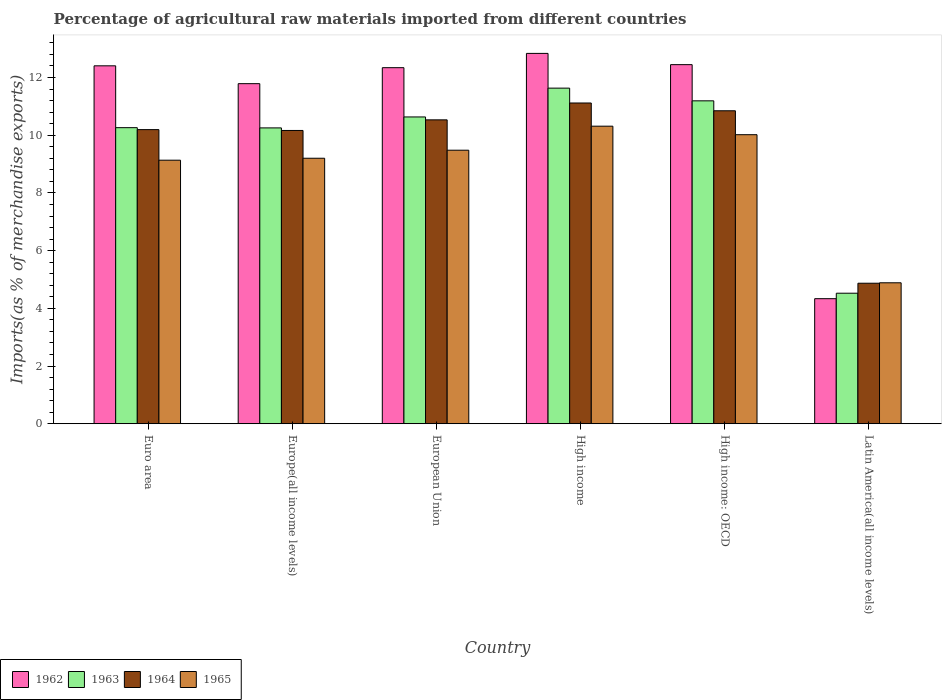How many different coloured bars are there?
Your answer should be very brief. 4. Are the number of bars per tick equal to the number of legend labels?
Give a very brief answer. Yes. Are the number of bars on each tick of the X-axis equal?
Offer a terse response. Yes. How many bars are there on the 6th tick from the left?
Offer a terse response. 4. How many bars are there on the 1st tick from the right?
Offer a very short reply. 4. What is the label of the 5th group of bars from the left?
Your response must be concise. High income: OECD. In how many cases, is the number of bars for a given country not equal to the number of legend labels?
Offer a very short reply. 0. What is the percentage of imports to different countries in 1965 in Latin America(all income levels)?
Give a very brief answer. 4.89. Across all countries, what is the maximum percentage of imports to different countries in 1964?
Your response must be concise. 11.12. Across all countries, what is the minimum percentage of imports to different countries in 1962?
Provide a short and direct response. 4.33. In which country was the percentage of imports to different countries in 1963 maximum?
Offer a very short reply. High income. In which country was the percentage of imports to different countries in 1964 minimum?
Your answer should be very brief. Latin America(all income levels). What is the total percentage of imports to different countries in 1965 in the graph?
Ensure brevity in your answer.  53.03. What is the difference between the percentage of imports to different countries in 1962 in Euro area and that in European Union?
Offer a very short reply. 0.06. What is the difference between the percentage of imports to different countries in 1965 in High income: OECD and the percentage of imports to different countries in 1963 in European Union?
Your response must be concise. -0.62. What is the average percentage of imports to different countries in 1965 per country?
Your response must be concise. 8.84. What is the difference between the percentage of imports to different countries of/in 1963 and percentage of imports to different countries of/in 1965 in Europe(all income levels)?
Keep it short and to the point. 1.05. In how many countries, is the percentage of imports to different countries in 1963 greater than 4 %?
Your answer should be compact. 6. What is the ratio of the percentage of imports to different countries in 1964 in Euro area to that in High income: OECD?
Your answer should be very brief. 0.94. Is the percentage of imports to different countries in 1964 in Euro area less than that in High income?
Provide a short and direct response. Yes. What is the difference between the highest and the second highest percentage of imports to different countries in 1962?
Ensure brevity in your answer.  0.39. What is the difference between the highest and the lowest percentage of imports to different countries in 1965?
Give a very brief answer. 5.43. In how many countries, is the percentage of imports to different countries in 1964 greater than the average percentage of imports to different countries in 1964 taken over all countries?
Keep it short and to the point. 5. Is it the case that in every country, the sum of the percentage of imports to different countries in 1964 and percentage of imports to different countries in 1963 is greater than the sum of percentage of imports to different countries in 1965 and percentage of imports to different countries in 1962?
Keep it short and to the point. No. What does the 4th bar from the left in Europe(all income levels) represents?
Provide a short and direct response. 1965. Is it the case that in every country, the sum of the percentage of imports to different countries in 1965 and percentage of imports to different countries in 1962 is greater than the percentage of imports to different countries in 1964?
Make the answer very short. Yes. How many bars are there?
Offer a terse response. 24. Are all the bars in the graph horizontal?
Ensure brevity in your answer.  No. How many countries are there in the graph?
Offer a terse response. 6. Does the graph contain any zero values?
Provide a succinct answer. No. How many legend labels are there?
Keep it short and to the point. 4. What is the title of the graph?
Keep it short and to the point. Percentage of agricultural raw materials imported from different countries. What is the label or title of the Y-axis?
Make the answer very short. Imports(as % of merchandise exports). What is the Imports(as % of merchandise exports) in 1962 in Euro area?
Your response must be concise. 12.41. What is the Imports(as % of merchandise exports) of 1963 in Euro area?
Offer a terse response. 10.26. What is the Imports(as % of merchandise exports) of 1964 in Euro area?
Give a very brief answer. 10.19. What is the Imports(as % of merchandise exports) of 1965 in Euro area?
Ensure brevity in your answer.  9.13. What is the Imports(as % of merchandise exports) in 1962 in Europe(all income levels)?
Your response must be concise. 11.79. What is the Imports(as % of merchandise exports) in 1963 in Europe(all income levels)?
Provide a succinct answer. 10.25. What is the Imports(as % of merchandise exports) of 1964 in Europe(all income levels)?
Ensure brevity in your answer.  10.17. What is the Imports(as % of merchandise exports) in 1965 in Europe(all income levels)?
Give a very brief answer. 9.2. What is the Imports(as % of merchandise exports) of 1962 in European Union?
Provide a short and direct response. 12.34. What is the Imports(as % of merchandise exports) of 1963 in European Union?
Your response must be concise. 10.63. What is the Imports(as % of merchandise exports) of 1964 in European Union?
Your answer should be very brief. 10.53. What is the Imports(as % of merchandise exports) in 1965 in European Union?
Offer a very short reply. 9.48. What is the Imports(as % of merchandise exports) in 1962 in High income?
Provide a short and direct response. 12.84. What is the Imports(as % of merchandise exports) of 1963 in High income?
Make the answer very short. 11.63. What is the Imports(as % of merchandise exports) in 1964 in High income?
Your answer should be compact. 11.12. What is the Imports(as % of merchandise exports) of 1965 in High income?
Offer a terse response. 10.31. What is the Imports(as % of merchandise exports) in 1962 in High income: OECD?
Your response must be concise. 12.45. What is the Imports(as % of merchandise exports) in 1963 in High income: OECD?
Your answer should be compact. 11.19. What is the Imports(as % of merchandise exports) of 1964 in High income: OECD?
Ensure brevity in your answer.  10.85. What is the Imports(as % of merchandise exports) in 1965 in High income: OECD?
Offer a terse response. 10.02. What is the Imports(as % of merchandise exports) in 1962 in Latin America(all income levels)?
Make the answer very short. 4.33. What is the Imports(as % of merchandise exports) in 1963 in Latin America(all income levels)?
Provide a short and direct response. 4.52. What is the Imports(as % of merchandise exports) in 1964 in Latin America(all income levels)?
Provide a succinct answer. 4.87. What is the Imports(as % of merchandise exports) of 1965 in Latin America(all income levels)?
Keep it short and to the point. 4.89. Across all countries, what is the maximum Imports(as % of merchandise exports) in 1962?
Give a very brief answer. 12.84. Across all countries, what is the maximum Imports(as % of merchandise exports) of 1963?
Make the answer very short. 11.63. Across all countries, what is the maximum Imports(as % of merchandise exports) of 1964?
Offer a very short reply. 11.12. Across all countries, what is the maximum Imports(as % of merchandise exports) of 1965?
Give a very brief answer. 10.31. Across all countries, what is the minimum Imports(as % of merchandise exports) in 1962?
Give a very brief answer. 4.33. Across all countries, what is the minimum Imports(as % of merchandise exports) in 1963?
Offer a terse response. 4.52. Across all countries, what is the minimum Imports(as % of merchandise exports) of 1964?
Keep it short and to the point. 4.87. Across all countries, what is the minimum Imports(as % of merchandise exports) of 1965?
Make the answer very short. 4.89. What is the total Imports(as % of merchandise exports) of 1962 in the graph?
Offer a terse response. 66.15. What is the total Imports(as % of merchandise exports) of 1963 in the graph?
Your answer should be compact. 58.5. What is the total Imports(as % of merchandise exports) in 1964 in the graph?
Offer a terse response. 57.73. What is the total Imports(as % of merchandise exports) of 1965 in the graph?
Provide a succinct answer. 53.03. What is the difference between the Imports(as % of merchandise exports) of 1962 in Euro area and that in Europe(all income levels)?
Offer a terse response. 0.62. What is the difference between the Imports(as % of merchandise exports) of 1963 in Euro area and that in Europe(all income levels)?
Give a very brief answer. 0.01. What is the difference between the Imports(as % of merchandise exports) of 1964 in Euro area and that in Europe(all income levels)?
Offer a terse response. 0.03. What is the difference between the Imports(as % of merchandise exports) of 1965 in Euro area and that in Europe(all income levels)?
Your response must be concise. -0.07. What is the difference between the Imports(as % of merchandise exports) in 1962 in Euro area and that in European Union?
Give a very brief answer. 0.06. What is the difference between the Imports(as % of merchandise exports) of 1963 in Euro area and that in European Union?
Your answer should be compact. -0.37. What is the difference between the Imports(as % of merchandise exports) of 1964 in Euro area and that in European Union?
Provide a short and direct response. -0.34. What is the difference between the Imports(as % of merchandise exports) of 1965 in Euro area and that in European Union?
Your response must be concise. -0.35. What is the difference between the Imports(as % of merchandise exports) of 1962 in Euro area and that in High income?
Your response must be concise. -0.43. What is the difference between the Imports(as % of merchandise exports) in 1963 in Euro area and that in High income?
Keep it short and to the point. -1.37. What is the difference between the Imports(as % of merchandise exports) in 1964 in Euro area and that in High income?
Your answer should be very brief. -0.92. What is the difference between the Imports(as % of merchandise exports) of 1965 in Euro area and that in High income?
Give a very brief answer. -1.18. What is the difference between the Imports(as % of merchandise exports) in 1962 in Euro area and that in High income: OECD?
Ensure brevity in your answer.  -0.04. What is the difference between the Imports(as % of merchandise exports) of 1963 in Euro area and that in High income: OECD?
Give a very brief answer. -0.93. What is the difference between the Imports(as % of merchandise exports) of 1964 in Euro area and that in High income: OECD?
Offer a terse response. -0.65. What is the difference between the Imports(as % of merchandise exports) in 1965 in Euro area and that in High income: OECD?
Offer a very short reply. -0.88. What is the difference between the Imports(as % of merchandise exports) in 1962 in Euro area and that in Latin America(all income levels)?
Make the answer very short. 8.07. What is the difference between the Imports(as % of merchandise exports) in 1963 in Euro area and that in Latin America(all income levels)?
Your answer should be very brief. 5.74. What is the difference between the Imports(as % of merchandise exports) of 1964 in Euro area and that in Latin America(all income levels)?
Provide a succinct answer. 5.32. What is the difference between the Imports(as % of merchandise exports) of 1965 in Euro area and that in Latin America(all income levels)?
Make the answer very short. 4.25. What is the difference between the Imports(as % of merchandise exports) in 1962 in Europe(all income levels) and that in European Union?
Give a very brief answer. -0.55. What is the difference between the Imports(as % of merchandise exports) of 1963 in Europe(all income levels) and that in European Union?
Provide a short and direct response. -0.38. What is the difference between the Imports(as % of merchandise exports) of 1964 in Europe(all income levels) and that in European Union?
Your response must be concise. -0.37. What is the difference between the Imports(as % of merchandise exports) of 1965 in Europe(all income levels) and that in European Union?
Provide a short and direct response. -0.28. What is the difference between the Imports(as % of merchandise exports) in 1962 in Europe(all income levels) and that in High income?
Provide a short and direct response. -1.05. What is the difference between the Imports(as % of merchandise exports) of 1963 in Europe(all income levels) and that in High income?
Your answer should be very brief. -1.38. What is the difference between the Imports(as % of merchandise exports) in 1964 in Europe(all income levels) and that in High income?
Your answer should be very brief. -0.95. What is the difference between the Imports(as % of merchandise exports) in 1965 in Europe(all income levels) and that in High income?
Ensure brevity in your answer.  -1.11. What is the difference between the Imports(as % of merchandise exports) in 1962 in Europe(all income levels) and that in High income: OECD?
Your answer should be compact. -0.66. What is the difference between the Imports(as % of merchandise exports) in 1963 in Europe(all income levels) and that in High income: OECD?
Offer a very short reply. -0.94. What is the difference between the Imports(as % of merchandise exports) of 1964 in Europe(all income levels) and that in High income: OECD?
Keep it short and to the point. -0.68. What is the difference between the Imports(as % of merchandise exports) in 1965 in Europe(all income levels) and that in High income: OECD?
Provide a succinct answer. -0.82. What is the difference between the Imports(as % of merchandise exports) of 1962 in Europe(all income levels) and that in Latin America(all income levels)?
Keep it short and to the point. 7.45. What is the difference between the Imports(as % of merchandise exports) in 1963 in Europe(all income levels) and that in Latin America(all income levels)?
Keep it short and to the point. 5.73. What is the difference between the Imports(as % of merchandise exports) in 1964 in Europe(all income levels) and that in Latin America(all income levels)?
Give a very brief answer. 5.29. What is the difference between the Imports(as % of merchandise exports) of 1965 in Europe(all income levels) and that in Latin America(all income levels)?
Give a very brief answer. 4.32. What is the difference between the Imports(as % of merchandise exports) in 1962 in European Union and that in High income?
Give a very brief answer. -0.5. What is the difference between the Imports(as % of merchandise exports) of 1963 in European Union and that in High income?
Your response must be concise. -1. What is the difference between the Imports(as % of merchandise exports) of 1964 in European Union and that in High income?
Your answer should be compact. -0.58. What is the difference between the Imports(as % of merchandise exports) in 1965 in European Union and that in High income?
Your answer should be very brief. -0.83. What is the difference between the Imports(as % of merchandise exports) of 1962 in European Union and that in High income: OECD?
Your answer should be very brief. -0.11. What is the difference between the Imports(as % of merchandise exports) of 1963 in European Union and that in High income: OECD?
Your answer should be compact. -0.56. What is the difference between the Imports(as % of merchandise exports) in 1964 in European Union and that in High income: OECD?
Give a very brief answer. -0.31. What is the difference between the Imports(as % of merchandise exports) of 1965 in European Union and that in High income: OECD?
Make the answer very short. -0.54. What is the difference between the Imports(as % of merchandise exports) of 1962 in European Union and that in Latin America(all income levels)?
Ensure brevity in your answer.  8.01. What is the difference between the Imports(as % of merchandise exports) of 1963 in European Union and that in Latin America(all income levels)?
Provide a short and direct response. 6.11. What is the difference between the Imports(as % of merchandise exports) in 1964 in European Union and that in Latin America(all income levels)?
Keep it short and to the point. 5.66. What is the difference between the Imports(as % of merchandise exports) of 1965 in European Union and that in Latin America(all income levels)?
Offer a terse response. 4.59. What is the difference between the Imports(as % of merchandise exports) of 1962 in High income and that in High income: OECD?
Offer a very short reply. 0.39. What is the difference between the Imports(as % of merchandise exports) in 1963 in High income and that in High income: OECD?
Ensure brevity in your answer.  0.44. What is the difference between the Imports(as % of merchandise exports) of 1964 in High income and that in High income: OECD?
Make the answer very short. 0.27. What is the difference between the Imports(as % of merchandise exports) of 1965 in High income and that in High income: OECD?
Give a very brief answer. 0.3. What is the difference between the Imports(as % of merchandise exports) of 1962 in High income and that in Latin America(all income levels)?
Make the answer very short. 8.5. What is the difference between the Imports(as % of merchandise exports) in 1963 in High income and that in Latin America(all income levels)?
Provide a short and direct response. 7.11. What is the difference between the Imports(as % of merchandise exports) of 1964 in High income and that in Latin America(all income levels)?
Keep it short and to the point. 6.25. What is the difference between the Imports(as % of merchandise exports) in 1965 in High income and that in Latin America(all income levels)?
Provide a short and direct response. 5.43. What is the difference between the Imports(as % of merchandise exports) in 1962 in High income: OECD and that in Latin America(all income levels)?
Ensure brevity in your answer.  8.11. What is the difference between the Imports(as % of merchandise exports) in 1963 in High income: OECD and that in Latin America(all income levels)?
Give a very brief answer. 6.67. What is the difference between the Imports(as % of merchandise exports) in 1964 in High income: OECD and that in Latin America(all income levels)?
Your answer should be compact. 5.98. What is the difference between the Imports(as % of merchandise exports) in 1965 in High income: OECD and that in Latin America(all income levels)?
Offer a terse response. 5.13. What is the difference between the Imports(as % of merchandise exports) of 1962 in Euro area and the Imports(as % of merchandise exports) of 1963 in Europe(all income levels)?
Offer a terse response. 2.15. What is the difference between the Imports(as % of merchandise exports) of 1962 in Euro area and the Imports(as % of merchandise exports) of 1964 in Europe(all income levels)?
Offer a terse response. 2.24. What is the difference between the Imports(as % of merchandise exports) in 1962 in Euro area and the Imports(as % of merchandise exports) in 1965 in Europe(all income levels)?
Keep it short and to the point. 3.2. What is the difference between the Imports(as % of merchandise exports) of 1963 in Euro area and the Imports(as % of merchandise exports) of 1964 in Europe(all income levels)?
Keep it short and to the point. 0.1. What is the difference between the Imports(as % of merchandise exports) in 1963 in Euro area and the Imports(as % of merchandise exports) in 1965 in Europe(all income levels)?
Provide a succinct answer. 1.06. What is the difference between the Imports(as % of merchandise exports) of 1962 in Euro area and the Imports(as % of merchandise exports) of 1963 in European Union?
Your response must be concise. 1.77. What is the difference between the Imports(as % of merchandise exports) of 1962 in Euro area and the Imports(as % of merchandise exports) of 1964 in European Union?
Ensure brevity in your answer.  1.87. What is the difference between the Imports(as % of merchandise exports) of 1962 in Euro area and the Imports(as % of merchandise exports) of 1965 in European Union?
Your answer should be very brief. 2.93. What is the difference between the Imports(as % of merchandise exports) in 1963 in Euro area and the Imports(as % of merchandise exports) in 1964 in European Union?
Ensure brevity in your answer.  -0.27. What is the difference between the Imports(as % of merchandise exports) of 1963 in Euro area and the Imports(as % of merchandise exports) of 1965 in European Union?
Offer a terse response. 0.78. What is the difference between the Imports(as % of merchandise exports) in 1964 in Euro area and the Imports(as % of merchandise exports) in 1965 in European Union?
Make the answer very short. 0.71. What is the difference between the Imports(as % of merchandise exports) of 1962 in Euro area and the Imports(as % of merchandise exports) of 1963 in High income?
Give a very brief answer. 0.77. What is the difference between the Imports(as % of merchandise exports) in 1962 in Euro area and the Imports(as % of merchandise exports) in 1964 in High income?
Your response must be concise. 1.29. What is the difference between the Imports(as % of merchandise exports) of 1962 in Euro area and the Imports(as % of merchandise exports) of 1965 in High income?
Your answer should be compact. 2.09. What is the difference between the Imports(as % of merchandise exports) of 1963 in Euro area and the Imports(as % of merchandise exports) of 1964 in High income?
Ensure brevity in your answer.  -0.86. What is the difference between the Imports(as % of merchandise exports) of 1963 in Euro area and the Imports(as % of merchandise exports) of 1965 in High income?
Your response must be concise. -0.05. What is the difference between the Imports(as % of merchandise exports) of 1964 in Euro area and the Imports(as % of merchandise exports) of 1965 in High income?
Your answer should be very brief. -0.12. What is the difference between the Imports(as % of merchandise exports) in 1962 in Euro area and the Imports(as % of merchandise exports) in 1963 in High income: OECD?
Give a very brief answer. 1.21. What is the difference between the Imports(as % of merchandise exports) in 1962 in Euro area and the Imports(as % of merchandise exports) in 1964 in High income: OECD?
Give a very brief answer. 1.56. What is the difference between the Imports(as % of merchandise exports) of 1962 in Euro area and the Imports(as % of merchandise exports) of 1965 in High income: OECD?
Your response must be concise. 2.39. What is the difference between the Imports(as % of merchandise exports) in 1963 in Euro area and the Imports(as % of merchandise exports) in 1964 in High income: OECD?
Provide a succinct answer. -0.59. What is the difference between the Imports(as % of merchandise exports) in 1963 in Euro area and the Imports(as % of merchandise exports) in 1965 in High income: OECD?
Ensure brevity in your answer.  0.24. What is the difference between the Imports(as % of merchandise exports) in 1964 in Euro area and the Imports(as % of merchandise exports) in 1965 in High income: OECD?
Offer a terse response. 0.18. What is the difference between the Imports(as % of merchandise exports) in 1962 in Euro area and the Imports(as % of merchandise exports) in 1963 in Latin America(all income levels)?
Your answer should be very brief. 7.88. What is the difference between the Imports(as % of merchandise exports) in 1962 in Euro area and the Imports(as % of merchandise exports) in 1964 in Latin America(all income levels)?
Keep it short and to the point. 7.54. What is the difference between the Imports(as % of merchandise exports) in 1962 in Euro area and the Imports(as % of merchandise exports) in 1965 in Latin America(all income levels)?
Your answer should be very brief. 7.52. What is the difference between the Imports(as % of merchandise exports) of 1963 in Euro area and the Imports(as % of merchandise exports) of 1964 in Latin America(all income levels)?
Your answer should be compact. 5.39. What is the difference between the Imports(as % of merchandise exports) in 1963 in Euro area and the Imports(as % of merchandise exports) in 1965 in Latin America(all income levels)?
Provide a succinct answer. 5.38. What is the difference between the Imports(as % of merchandise exports) in 1964 in Euro area and the Imports(as % of merchandise exports) in 1965 in Latin America(all income levels)?
Your answer should be compact. 5.31. What is the difference between the Imports(as % of merchandise exports) in 1962 in Europe(all income levels) and the Imports(as % of merchandise exports) in 1963 in European Union?
Offer a terse response. 1.15. What is the difference between the Imports(as % of merchandise exports) of 1962 in Europe(all income levels) and the Imports(as % of merchandise exports) of 1964 in European Union?
Keep it short and to the point. 1.25. What is the difference between the Imports(as % of merchandise exports) in 1962 in Europe(all income levels) and the Imports(as % of merchandise exports) in 1965 in European Union?
Provide a succinct answer. 2.31. What is the difference between the Imports(as % of merchandise exports) in 1963 in Europe(all income levels) and the Imports(as % of merchandise exports) in 1964 in European Union?
Offer a very short reply. -0.28. What is the difference between the Imports(as % of merchandise exports) of 1963 in Europe(all income levels) and the Imports(as % of merchandise exports) of 1965 in European Union?
Offer a very short reply. 0.77. What is the difference between the Imports(as % of merchandise exports) in 1964 in Europe(all income levels) and the Imports(as % of merchandise exports) in 1965 in European Union?
Ensure brevity in your answer.  0.68. What is the difference between the Imports(as % of merchandise exports) of 1962 in Europe(all income levels) and the Imports(as % of merchandise exports) of 1963 in High income?
Make the answer very short. 0.15. What is the difference between the Imports(as % of merchandise exports) in 1962 in Europe(all income levels) and the Imports(as % of merchandise exports) in 1964 in High income?
Your answer should be very brief. 0.67. What is the difference between the Imports(as % of merchandise exports) of 1962 in Europe(all income levels) and the Imports(as % of merchandise exports) of 1965 in High income?
Your response must be concise. 1.47. What is the difference between the Imports(as % of merchandise exports) in 1963 in Europe(all income levels) and the Imports(as % of merchandise exports) in 1964 in High income?
Ensure brevity in your answer.  -0.86. What is the difference between the Imports(as % of merchandise exports) in 1963 in Europe(all income levels) and the Imports(as % of merchandise exports) in 1965 in High income?
Your answer should be compact. -0.06. What is the difference between the Imports(as % of merchandise exports) of 1964 in Europe(all income levels) and the Imports(as % of merchandise exports) of 1965 in High income?
Ensure brevity in your answer.  -0.15. What is the difference between the Imports(as % of merchandise exports) of 1962 in Europe(all income levels) and the Imports(as % of merchandise exports) of 1963 in High income: OECD?
Ensure brevity in your answer.  0.59. What is the difference between the Imports(as % of merchandise exports) of 1962 in Europe(all income levels) and the Imports(as % of merchandise exports) of 1964 in High income: OECD?
Provide a succinct answer. 0.94. What is the difference between the Imports(as % of merchandise exports) in 1962 in Europe(all income levels) and the Imports(as % of merchandise exports) in 1965 in High income: OECD?
Your answer should be very brief. 1.77. What is the difference between the Imports(as % of merchandise exports) in 1963 in Europe(all income levels) and the Imports(as % of merchandise exports) in 1964 in High income: OECD?
Your answer should be very brief. -0.59. What is the difference between the Imports(as % of merchandise exports) in 1963 in Europe(all income levels) and the Imports(as % of merchandise exports) in 1965 in High income: OECD?
Make the answer very short. 0.24. What is the difference between the Imports(as % of merchandise exports) in 1964 in Europe(all income levels) and the Imports(as % of merchandise exports) in 1965 in High income: OECD?
Your response must be concise. 0.15. What is the difference between the Imports(as % of merchandise exports) of 1962 in Europe(all income levels) and the Imports(as % of merchandise exports) of 1963 in Latin America(all income levels)?
Keep it short and to the point. 7.26. What is the difference between the Imports(as % of merchandise exports) in 1962 in Europe(all income levels) and the Imports(as % of merchandise exports) in 1964 in Latin America(all income levels)?
Ensure brevity in your answer.  6.92. What is the difference between the Imports(as % of merchandise exports) in 1962 in Europe(all income levels) and the Imports(as % of merchandise exports) in 1965 in Latin America(all income levels)?
Ensure brevity in your answer.  6.9. What is the difference between the Imports(as % of merchandise exports) in 1963 in Europe(all income levels) and the Imports(as % of merchandise exports) in 1964 in Latin America(all income levels)?
Keep it short and to the point. 5.38. What is the difference between the Imports(as % of merchandise exports) of 1963 in Europe(all income levels) and the Imports(as % of merchandise exports) of 1965 in Latin America(all income levels)?
Your answer should be compact. 5.37. What is the difference between the Imports(as % of merchandise exports) of 1964 in Europe(all income levels) and the Imports(as % of merchandise exports) of 1965 in Latin America(all income levels)?
Ensure brevity in your answer.  5.28. What is the difference between the Imports(as % of merchandise exports) in 1962 in European Union and the Imports(as % of merchandise exports) in 1963 in High income?
Offer a very short reply. 0.71. What is the difference between the Imports(as % of merchandise exports) of 1962 in European Union and the Imports(as % of merchandise exports) of 1964 in High income?
Provide a succinct answer. 1.22. What is the difference between the Imports(as % of merchandise exports) in 1962 in European Union and the Imports(as % of merchandise exports) in 1965 in High income?
Your answer should be very brief. 2.03. What is the difference between the Imports(as % of merchandise exports) in 1963 in European Union and the Imports(as % of merchandise exports) in 1964 in High income?
Offer a very short reply. -0.48. What is the difference between the Imports(as % of merchandise exports) in 1963 in European Union and the Imports(as % of merchandise exports) in 1965 in High income?
Your answer should be very brief. 0.32. What is the difference between the Imports(as % of merchandise exports) in 1964 in European Union and the Imports(as % of merchandise exports) in 1965 in High income?
Offer a terse response. 0.22. What is the difference between the Imports(as % of merchandise exports) of 1962 in European Union and the Imports(as % of merchandise exports) of 1963 in High income: OECD?
Your answer should be very brief. 1.15. What is the difference between the Imports(as % of merchandise exports) of 1962 in European Union and the Imports(as % of merchandise exports) of 1964 in High income: OECD?
Your answer should be compact. 1.49. What is the difference between the Imports(as % of merchandise exports) of 1962 in European Union and the Imports(as % of merchandise exports) of 1965 in High income: OECD?
Your answer should be very brief. 2.32. What is the difference between the Imports(as % of merchandise exports) of 1963 in European Union and the Imports(as % of merchandise exports) of 1964 in High income: OECD?
Make the answer very short. -0.21. What is the difference between the Imports(as % of merchandise exports) in 1963 in European Union and the Imports(as % of merchandise exports) in 1965 in High income: OECD?
Offer a very short reply. 0.62. What is the difference between the Imports(as % of merchandise exports) in 1964 in European Union and the Imports(as % of merchandise exports) in 1965 in High income: OECD?
Your answer should be compact. 0.51. What is the difference between the Imports(as % of merchandise exports) in 1962 in European Union and the Imports(as % of merchandise exports) in 1963 in Latin America(all income levels)?
Make the answer very short. 7.82. What is the difference between the Imports(as % of merchandise exports) in 1962 in European Union and the Imports(as % of merchandise exports) in 1964 in Latin America(all income levels)?
Ensure brevity in your answer.  7.47. What is the difference between the Imports(as % of merchandise exports) of 1962 in European Union and the Imports(as % of merchandise exports) of 1965 in Latin America(all income levels)?
Provide a short and direct response. 7.46. What is the difference between the Imports(as % of merchandise exports) in 1963 in European Union and the Imports(as % of merchandise exports) in 1964 in Latin America(all income levels)?
Provide a succinct answer. 5.76. What is the difference between the Imports(as % of merchandise exports) in 1963 in European Union and the Imports(as % of merchandise exports) in 1965 in Latin America(all income levels)?
Make the answer very short. 5.75. What is the difference between the Imports(as % of merchandise exports) of 1964 in European Union and the Imports(as % of merchandise exports) of 1965 in Latin America(all income levels)?
Provide a succinct answer. 5.65. What is the difference between the Imports(as % of merchandise exports) of 1962 in High income and the Imports(as % of merchandise exports) of 1963 in High income: OECD?
Ensure brevity in your answer.  1.64. What is the difference between the Imports(as % of merchandise exports) in 1962 in High income and the Imports(as % of merchandise exports) in 1964 in High income: OECD?
Give a very brief answer. 1.99. What is the difference between the Imports(as % of merchandise exports) of 1962 in High income and the Imports(as % of merchandise exports) of 1965 in High income: OECD?
Keep it short and to the point. 2.82. What is the difference between the Imports(as % of merchandise exports) in 1963 in High income and the Imports(as % of merchandise exports) in 1964 in High income: OECD?
Ensure brevity in your answer.  0.78. What is the difference between the Imports(as % of merchandise exports) of 1963 in High income and the Imports(as % of merchandise exports) of 1965 in High income: OECD?
Your answer should be compact. 1.61. What is the difference between the Imports(as % of merchandise exports) in 1964 in High income and the Imports(as % of merchandise exports) in 1965 in High income: OECD?
Your answer should be very brief. 1.1. What is the difference between the Imports(as % of merchandise exports) in 1962 in High income and the Imports(as % of merchandise exports) in 1963 in Latin America(all income levels)?
Offer a very short reply. 8.31. What is the difference between the Imports(as % of merchandise exports) in 1962 in High income and the Imports(as % of merchandise exports) in 1964 in Latin America(all income levels)?
Give a very brief answer. 7.97. What is the difference between the Imports(as % of merchandise exports) of 1962 in High income and the Imports(as % of merchandise exports) of 1965 in Latin America(all income levels)?
Keep it short and to the point. 7.95. What is the difference between the Imports(as % of merchandise exports) in 1963 in High income and the Imports(as % of merchandise exports) in 1964 in Latin America(all income levels)?
Your answer should be very brief. 6.76. What is the difference between the Imports(as % of merchandise exports) of 1963 in High income and the Imports(as % of merchandise exports) of 1965 in Latin America(all income levels)?
Offer a very short reply. 6.75. What is the difference between the Imports(as % of merchandise exports) of 1964 in High income and the Imports(as % of merchandise exports) of 1965 in Latin America(all income levels)?
Provide a short and direct response. 6.23. What is the difference between the Imports(as % of merchandise exports) in 1962 in High income: OECD and the Imports(as % of merchandise exports) in 1963 in Latin America(all income levels)?
Give a very brief answer. 7.92. What is the difference between the Imports(as % of merchandise exports) of 1962 in High income: OECD and the Imports(as % of merchandise exports) of 1964 in Latin America(all income levels)?
Your response must be concise. 7.58. What is the difference between the Imports(as % of merchandise exports) of 1962 in High income: OECD and the Imports(as % of merchandise exports) of 1965 in Latin America(all income levels)?
Your response must be concise. 7.56. What is the difference between the Imports(as % of merchandise exports) in 1963 in High income: OECD and the Imports(as % of merchandise exports) in 1964 in Latin America(all income levels)?
Provide a short and direct response. 6.32. What is the difference between the Imports(as % of merchandise exports) in 1963 in High income: OECD and the Imports(as % of merchandise exports) in 1965 in Latin America(all income levels)?
Offer a very short reply. 6.31. What is the difference between the Imports(as % of merchandise exports) in 1964 in High income: OECD and the Imports(as % of merchandise exports) in 1965 in Latin America(all income levels)?
Make the answer very short. 5.96. What is the average Imports(as % of merchandise exports) in 1962 per country?
Ensure brevity in your answer.  11.03. What is the average Imports(as % of merchandise exports) in 1963 per country?
Offer a very short reply. 9.75. What is the average Imports(as % of merchandise exports) of 1964 per country?
Your answer should be compact. 9.62. What is the average Imports(as % of merchandise exports) of 1965 per country?
Make the answer very short. 8.84. What is the difference between the Imports(as % of merchandise exports) in 1962 and Imports(as % of merchandise exports) in 1963 in Euro area?
Your response must be concise. 2.14. What is the difference between the Imports(as % of merchandise exports) of 1962 and Imports(as % of merchandise exports) of 1964 in Euro area?
Offer a very short reply. 2.21. What is the difference between the Imports(as % of merchandise exports) of 1962 and Imports(as % of merchandise exports) of 1965 in Euro area?
Offer a very short reply. 3.27. What is the difference between the Imports(as % of merchandise exports) in 1963 and Imports(as % of merchandise exports) in 1964 in Euro area?
Keep it short and to the point. 0.07. What is the difference between the Imports(as % of merchandise exports) in 1963 and Imports(as % of merchandise exports) in 1965 in Euro area?
Offer a very short reply. 1.13. What is the difference between the Imports(as % of merchandise exports) of 1964 and Imports(as % of merchandise exports) of 1965 in Euro area?
Your answer should be very brief. 1.06. What is the difference between the Imports(as % of merchandise exports) of 1962 and Imports(as % of merchandise exports) of 1963 in Europe(all income levels)?
Make the answer very short. 1.53. What is the difference between the Imports(as % of merchandise exports) of 1962 and Imports(as % of merchandise exports) of 1964 in Europe(all income levels)?
Ensure brevity in your answer.  1.62. What is the difference between the Imports(as % of merchandise exports) in 1962 and Imports(as % of merchandise exports) in 1965 in Europe(all income levels)?
Your answer should be very brief. 2.58. What is the difference between the Imports(as % of merchandise exports) in 1963 and Imports(as % of merchandise exports) in 1964 in Europe(all income levels)?
Provide a short and direct response. 0.09. What is the difference between the Imports(as % of merchandise exports) in 1963 and Imports(as % of merchandise exports) in 1965 in Europe(all income levels)?
Offer a very short reply. 1.05. What is the difference between the Imports(as % of merchandise exports) in 1964 and Imports(as % of merchandise exports) in 1965 in Europe(all income levels)?
Ensure brevity in your answer.  0.96. What is the difference between the Imports(as % of merchandise exports) in 1962 and Imports(as % of merchandise exports) in 1963 in European Union?
Your answer should be compact. 1.71. What is the difference between the Imports(as % of merchandise exports) of 1962 and Imports(as % of merchandise exports) of 1964 in European Union?
Keep it short and to the point. 1.81. What is the difference between the Imports(as % of merchandise exports) in 1962 and Imports(as % of merchandise exports) in 1965 in European Union?
Your answer should be very brief. 2.86. What is the difference between the Imports(as % of merchandise exports) of 1963 and Imports(as % of merchandise exports) of 1964 in European Union?
Provide a short and direct response. 0.1. What is the difference between the Imports(as % of merchandise exports) in 1963 and Imports(as % of merchandise exports) in 1965 in European Union?
Ensure brevity in your answer.  1.15. What is the difference between the Imports(as % of merchandise exports) in 1964 and Imports(as % of merchandise exports) in 1965 in European Union?
Provide a succinct answer. 1.05. What is the difference between the Imports(as % of merchandise exports) of 1962 and Imports(as % of merchandise exports) of 1963 in High income?
Provide a succinct answer. 1.2. What is the difference between the Imports(as % of merchandise exports) of 1962 and Imports(as % of merchandise exports) of 1964 in High income?
Make the answer very short. 1.72. What is the difference between the Imports(as % of merchandise exports) of 1962 and Imports(as % of merchandise exports) of 1965 in High income?
Provide a short and direct response. 2.52. What is the difference between the Imports(as % of merchandise exports) of 1963 and Imports(as % of merchandise exports) of 1964 in High income?
Your answer should be compact. 0.52. What is the difference between the Imports(as % of merchandise exports) of 1963 and Imports(as % of merchandise exports) of 1965 in High income?
Keep it short and to the point. 1.32. What is the difference between the Imports(as % of merchandise exports) of 1964 and Imports(as % of merchandise exports) of 1965 in High income?
Your answer should be very brief. 0.8. What is the difference between the Imports(as % of merchandise exports) in 1962 and Imports(as % of merchandise exports) in 1963 in High income: OECD?
Your response must be concise. 1.25. What is the difference between the Imports(as % of merchandise exports) in 1962 and Imports(as % of merchandise exports) in 1964 in High income: OECD?
Your answer should be compact. 1.6. What is the difference between the Imports(as % of merchandise exports) in 1962 and Imports(as % of merchandise exports) in 1965 in High income: OECD?
Provide a short and direct response. 2.43. What is the difference between the Imports(as % of merchandise exports) of 1963 and Imports(as % of merchandise exports) of 1964 in High income: OECD?
Your response must be concise. 0.34. What is the difference between the Imports(as % of merchandise exports) of 1963 and Imports(as % of merchandise exports) of 1965 in High income: OECD?
Provide a short and direct response. 1.17. What is the difference between the Imports(as % of merchandise exports) of 1964 and Imports(as % of merchandise exports) of 1965 in High income: OECD?
Provide a short and direct response. 0.83. What is the difference between the Imports(as % of merchandise exports) in 1962 and Imports(as % of merchandise exports) in 1963 in Latin America(all income levels)?
Your answer should be very brief. -0.19. What is the difference between the Imports(as % of merchandise exports) of 1962 and Imports(as % of merchandise exports) of 1964 in Latin America(all income levels)?
Offer a very short reply. -0.54. What is the difference between the Imports(as % of merchandise exports) of 1962 and Imports(as % of merchandise exports) of 1965 in Latin America(all income levels)?
Ensure brevity in your answer.  -0.55. What is the difference between the Imports(as % of merchandise exports) of 1963 and Imports(as % of merchandise exports) of 1964 in Latin America(all income levels)?
Offer a terse response. -0.35. What is the difference between the Imports(as % of merchandise exports) in 1963 and Imports(as % of merchandise exports) in 1965 in Latin America(all income levels)?
Your response must be concise. -0.36. What is the difference between the Imports(as % of merchandise exports) in 1964 and Imports(as % of merchandise exports) in 1965 in Latin America(all income levels)?
Your response must be concise. -0.02. What is the ratio of the Imports(as % of merchandise exports) in 1962 in Euro area to that in Europe(all income levels)?
Ensure brevity in your answer.  1.05. What is the ratio of the Imports(as % of merchandise exports) in 1965 in Euro area to that in Europe(all income levels)?
Make the answer very short. 0.99. What is the ratio of the Imports(as % of merchandise exports) in 1962 in Euro area to that in European Union?
Provide a short and direct response. 1.01. What is the ratio of the Imports(as % of merchandise exports) in 1963 in Euro area to that in European Union?
Keep it short and to the point. 0.96. What is the ratio of the Imports(as % of merchandise exports) in 1964 in Euro area to that in European Union?
Give a very brief answer. 0.97. What is the ratio of the Imports(as % of merchandise exports) of 1965 in Euro area to that in European Union?
Keep it short and to the point. 0.96. What is the ratio of the Imports(as % of merchandise exports) of 1962 in Euro area to that in High income?
Keep it short and to the point. 0.97. What is the ratio of the Imports(as % of merchandise exports) of 1963 in Euro area to that in High income?
Your answer should be very brief. 0.88. What is the ratio of the Imports(as % of merchandise exports) of 1964 in Euro area to that in High income?
Provide a succinct answer. 0.92. What is the ratio of the Imports(as % of merchandise exports) in 1965 in Euro area to that in High income?
Provide a succinct answer. 0.89. What is the ratio of the Imports(as % of merchandise exports) of 1962 in Euro area to that in High income: OECD?
Offer a very short reply. 1. What is the ratio of the Imports(as % of merchandise exports) of 1963 in Euro area to that in High income: OECD?
Provide a short and direct response. 0.92. What is the ratio of the Imports(as % of merchandise exports) of 1964 in Euro area to that in High income: OECD?
Ensure brevity in your answer.  0.94. What is the ratio of the Imports(as % of merchandise exports) in 1965 in Euro area to that in High income: OECD?
Ensure brevity in your answer.  0.91. What is the ratio of the Imports(as % of merchandise exports) of 1962 in Euro area to that in Latin America(all income levels)?
Offer a terse response. 2.86. What is the ratio of the Imports(as % of merchandise exports) of 1963 in Euro area to that in Latin America(all income levels)?
Offer a terse response. 2.27. What is the ratio of the Imports(as % of merchandise exports) in 1964 in Euro area to that in Latin America(all income levels)?
Ensure brevity in your answer.  2.09. What is the ratio of the Imports(as % of merchandise exports) of 1965 in Euro area to that in Latin America(all income levels)?
Ensure brevity in your answer.  1.87. What is the ratio of the Imports(as % of merchandise exports) in 1962 in Europe(all income levels) to that in European Union?
Keep it short and to the point. 0.96. What is the ratio of the Imports(as % of merchandise exports) in 1964 in Europe(all income levels) to that in European Union?
Make the answer very short. 0.97. What is the ratio of the Imports(as % of merchandise exports) in 1965 in Europe(all income levels) to that in European Union?
Provide a succinct answer. 0.97. What is the ratio of the Imports(as % of merchandise exports) of 1962 in Europe(all income levels) to that in High income?
Offer a very short reply. 0.92. What is the ratio of the Imports(as % of merchandise exports) in 1963 in Europe(all income levels) to that in High income?
Offer a very short reply. 0.88. What is the ratio of the Imports(as % of merchandise exports) of 1964 in Europe(all income levels) to that in High income?
Provide a succinct answer. 0.91. What is the ratio of the Imports(as % of merchandise exports) in 1965 in Europe(all income levels) to that in High income?
Offer a terse response. 0.89. What is the ratio of the Imports(as % of merchandise exports) of 1962 in Europe(all income levels) to that in High income: OECD?
Your answer should be compact. 0.95. What is the ratio of the Imports(as % of merchandise exports) in 1963 in Europe(all income levels) to that in High income: OECD?
Your answer should be compact. 0.92. What is the ratio of the Imports(as % of merchandise exports) in 1964 in Europe(all income levels) to that in High income: OECD?
Provide a succinct answer. 0.94. What is the ratio of the Imports(as % of merchandise exports) of 1965 in Europe(all income levels) to that in High income: OECD?
Make the answer very short. 0.92. What is the ratio of the Imports(as % of merchandise exports) of 1962 in Europe(all income levels) to that in Latin America(all income levels)?
Your response must be concise. 2.72. What is the ratio of the Imports(as % of merchandise exports) in 1963 in Europe(all income levels) to that in Latin America(all income levels)?
Your response must be concise. 2.27. What is the ratio of the Imports(as % of merchandise exports) in 1964 in Europe(all income levels) to that in Latin America(all income levels)?
Keep it short and to the point. 2.09. What is the ratio of the Imports(as % of merchandise exports) of 1965 in Europe(all income levels) to that in Latin America(all income levels)?
Provide a short and direct response. 1.88. What is the ratio of the Imports(as % of merchandise exports) of 1962 in European Union to that in High income?
Provide a succinct answer. 0.96. What is the ratio of the Imports(as % of merchandise exports) of 1963 in European Union to that in High income?
Give a very brief answer. 0.91. What is the ratio of the Imports(as % of merchandise exports) of 1964 in European Union to that in High income?
Your response must be concise. 0.95. What is the ratio of the Imports(as % of merchandise exports) in 1965 in European Union to that in High income?
Provide a succinct answer. 0.92. What is the ratio of the Imports(as % of merchandise exports) of 1963 in European Union to that in High income: OECD?
Make the answer very short. 0.95. What is the ratio of the Imports(as % of merchandise exports) in 1964 in European Union to that in High income: OECD?
Your response must be concise. 0.97. What is the ratio of the Imports(as % of merchandise exports) in 1965 in European Union to that in High income: OECD?
Your response must be concise. 0.95. What is the ratio of the Imports(as % of merchandise exports) in 1962 in European Union to that in Latin America(all income levels)?
Provide a short and direct response. 2.85. What is the ratio of the Imports(as % of merchandise exports) in 1963 in European Union to that in Latin America(all income levels)?
Offer a very short reply. 2.35. What is the ratio of the Imports(as % of merchandise exports) in 1964 in European Union to that in Latin America(all income levels)?
Provide a short and direct response. 2.16. What is the ratio of the Imports(as % of merchandise exports) in 1965 in European Union to that in Latin America(all income levels)?
Your answer should be very brief. 1.94. What is the ratio of the Imports(as % of merchandise exports) of 1962 in High income to that in High income: OECD?
Your response must be concise. 1.03. What is the ratio of the Imports(as % of merchandise exports) of 1963 in High income to that in High income: OECD?
Your answer should be compact. 1.04. What is the ratio of the Imports(as % of merchandise exports) of 1964 in High income to that in High income: OECD?
Provide a short and direct response. 1.02. What is the ratio of the Imports(as % of merchandise exports) of 1965 in High income to that in High income: OECD?
Ensure brevity in your answer.  1.03. What is the ratio of the Imports(as % of merchandise exports) in 1962 in High income to that in Latin America(all income levels)?
Make the answer very short. 2.96. What is the ratio of the Imports(as % of merchandise exports) of 1963 in High income to that in Latin America(all income levels)?
Offer a very short reply. 2.57. What is the ratio of the Imports(as % of merchandise exports) in 1964 in High income to that in Latin America(all income levels)?
Give a very brief answer. 2.28. What is the ratio of the Imports(as % of merchandise exports) in 1965 in High income to that in Latin America(all income levels)?
Your answer should be compact. 2.11. What is the ratio of the Imports(as % of merchandise exports) in 1962 in High income: OECD to that in Latin America(all income levels)?
Your response must be concise. 2.87. What is the ratio of the Imports(as % of merchandise exports) of 1963 in High income: OECD to that in Latin America(all income levels)?
Your answer should be very brief. 2.47. What is the ratio of the Imports(as % of merchandise exports) of 1964 in High income: OECD to that in Latin America(all income levels)?
Offer a terse response. 2.23. What is the ratio of the Imports(as % of merchandise exports) of 1965 in High income: OECD to that in Latin America(all income levels)?
Provide a succinct answer. 2.05. What is the difference between the highest and the second highest Imports(as % of merchandise exports) of 1962?
Keep it short and to the point. 0.39. What is the difference between the highest and the second highest Imports(as % of merchandise exports) of 1963?
Make the answer very short. 0.44. What is the difference between the highest and the second highest Imports(as % of merchandise exports) of 1964?
Provide a short and direct response. 0.27. What is the difference between the highest and the second highest Imports(as % of merchandise exports) of 1965?
Keep it short and to the point. 0.3. What is the difference between the highest and the lowest Imports(as % of merchandise exports) in 1962?
Give a very brief answer. 8.5. What is the difference between the highest and the lowest Imports(as % of merchandise exports) of 1963?
Your response must be concise. 7.11. What is the difference between the highest and the lowest Imports(as % of merchandise exports) of 1964?
Offer a terse response. 6.25. What is the difference between the highest and the lowest Imports(as % of merchandise exports) in 1965?
Your response must be concise. 5.43. 